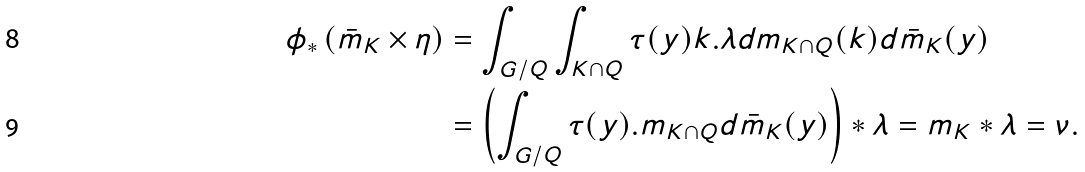<formula> <loc_0><loc_0><loc_500><loc_500>\phi _ { \ast } \left ( \bar { m } _ { K } \times \eta \right ) & = \int _ { G / Q } \int _ { K \cap Q } \tau ( y ) k . \lambda d m _ { K \cap Q } ( k ) d \bar { m } _ { K } ( y ) \\ & = \left ( \int _ { G / Q } \tau ( y ) . m _ { K \cap Q } d \bar { m } _ { K } ( y ) \right ) \ast \lambda = m _ { K } \ast \lambda = \nu .</formula> 